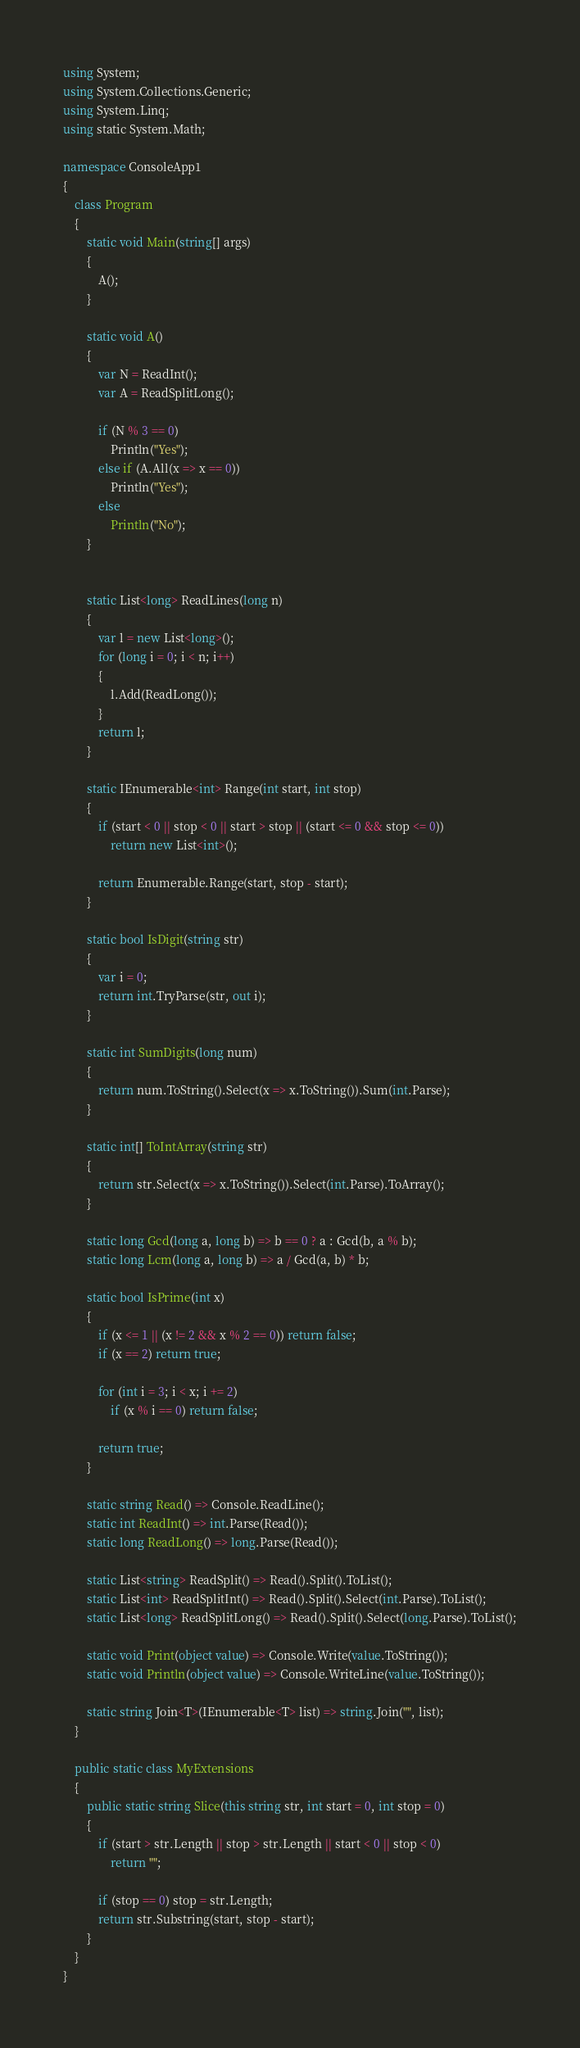<code> <loc_0><loc_0><loc_500><loc_500><_C#_>using System;
using System.Collections.Generic;
using System.Linq;
using static System.Math;

namespace ConsoleApp1
{
    class Program
    {
        static void Main(string[] args)
        {
            A();
        }

        static void A()
        {
            var N = ReadInt();
            var A = ReadSplitLong();

            if (N % 3 == 0)
                Println("Yes");
            else if (A.All(x => x == 0))
                Println("Yes");
            else
                Println("No");
        }


        static List<long> ReadLines(long n)
        {
            var l = new List<long>();
            for (long i = 0; i < n; i++)
            {
                l.Add(ReadLong());
            }
            return l;
        }

        static IEnumerable<int> Range(int start, int stop)
        {
            if (start < 0 || stop < 0 || start > stop || (start <= 0 && stop <= 0))
                return new List<int>();

            return Enumerable.Range(start, stop - start);
        }

        static bool IsDigit(string str)
        {
            var i = 0;
            return int.TryParse(str, out i);
        }

        static int SumDigits(long num)
        {
            return num.ToString().Select(x => x.ToString()).Sum(int.Parse);
        }

        static int[] ToIntArray(string str)
        {
            return str.Select(x => x.ToString()).Select(int.Parse).ToArray();
        }

        static long Gcd(long a, long b) => b == 0 ? a : Gcd(b, a % b);
        static long Lcm(long a, long b) => a / Gcd(a, b) * b;

        static bool IsPrime(int x)
        {
            if (x <= 1 || (x != 2 && x % 2 == 0)) return false;
            if (x == 2) return true;

            for (int i = 3; i < x; i += 2)
                if (x % i == 0) return false;

            return true;
        }

        static string Read() => Console.ReadLine();
        static int ReadInt() => int.Parse(Read());
        static long ReadLong() => long.Parse(Read());

        static List<string> ReadSplit() => Read().Split().ToList();
        static List<int> ReadSplitInt() => Read().Split().Select(int.Parse).ToList();
        static List<long> ReadSplitLong() => Read().Split().Select(long.Parse).ToList();

        static void Print(object value) => Console.Write(value.ToString());
        static void Println(object value) => Console.WriteLine(value.ToString());

        static string Join<T>(IEnumerable<T> list) => string.Join("", list);
    }

    public static class MyExtensions
    {
        public static string Slice(this string str, int start = 0, int stop = 0)
        {
            if (start > str.Length || stop > str.Length || start < 0 || stop < 0)
                return "";

            if (stop == 0) stop = str.Length;
            return str.Substring(start, stop - start);
        }
    }
}
</code> 